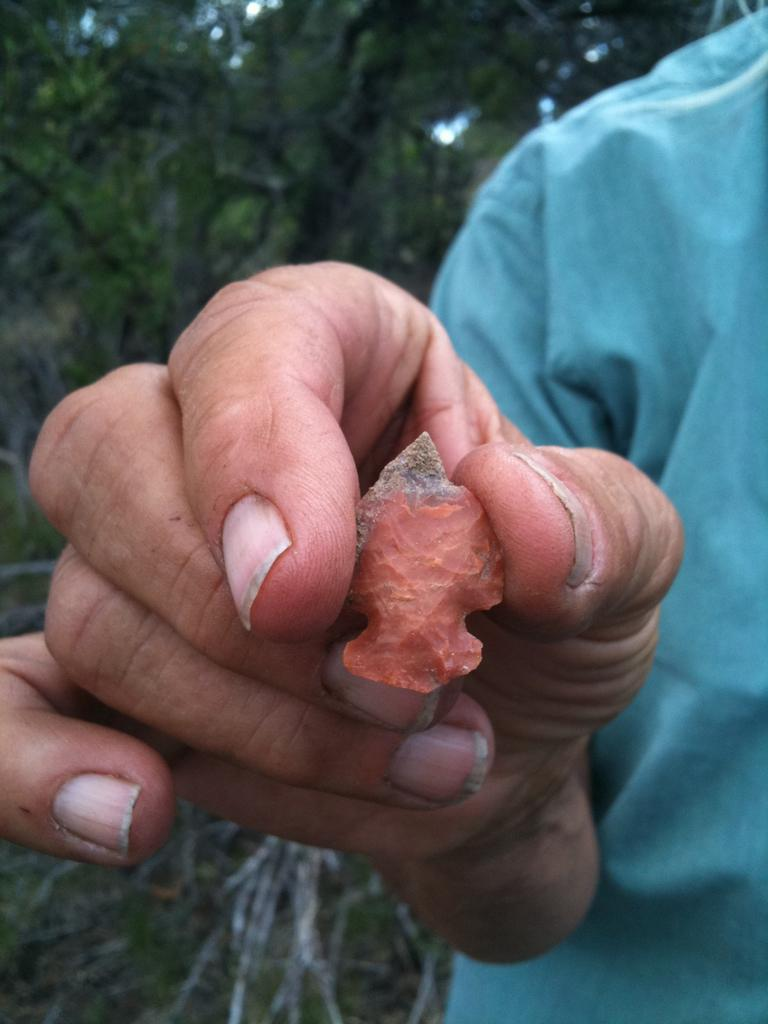What can be seen in the image? There is a person in the image. What is the person wearing? The person is wearing a blue shirt. What is the person holding in the image? The person is holding a stone with one hand. What can be seen in the background of the image? There are trees and plants in the background of the image. What type of straw is the person using to turn the page in the image? There is no straw or page present in the image. 